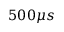<formula> <loc_0><loc_0><loc_500><loc_500>5 0 0 \mu s</formula> 